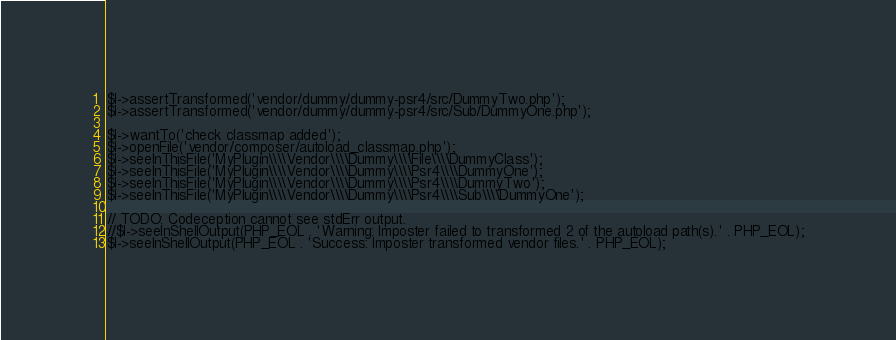<code> <loc_0><loc_0><loc_500><loc_500><_PHP_>$I->assertTransformed('vendor/dummy/dummy-psr4/src/DummyTwo.php');
$I->assertTransformed('vendor/dummy/dummy-psr4/src/Sub/DummyOne.php');

$I->wantTo('check classmap added');
$I->openFile('vendor/composer/autoload_classmap.php');
$I->seeInThisFile('MyPlugin\\\\Vendor\\\\Dummy\\\\File\\\\DummyClass');
$I->seeInThisFile('MyPlugin\\\\Vendor\\\\Dummy\\\\Psr4\\\\DummyOne');
$I->seeInThisFile('MyPlugin\\\\Vendor\\\\Dummy\\\\Psr4\\\\DummyTwo');
$I->seeInThisFile('MyPlugin\\\\Vendor\\\\Dummy\\\\Psr4\\\\Sub\\\\DummyOne');

// TODO: Codeception cannot see stdErr output.
//$I->seeInShellOutput(PHP_EOL . 'Warning: Imposter failed to transformed 2 of the autoload path(s).' . PHP_EOL);
$I->seeInShellOutput(PHP_EOL . 'Success: Imposter transformed vendor files.' . PHP_EOL);
</code> 